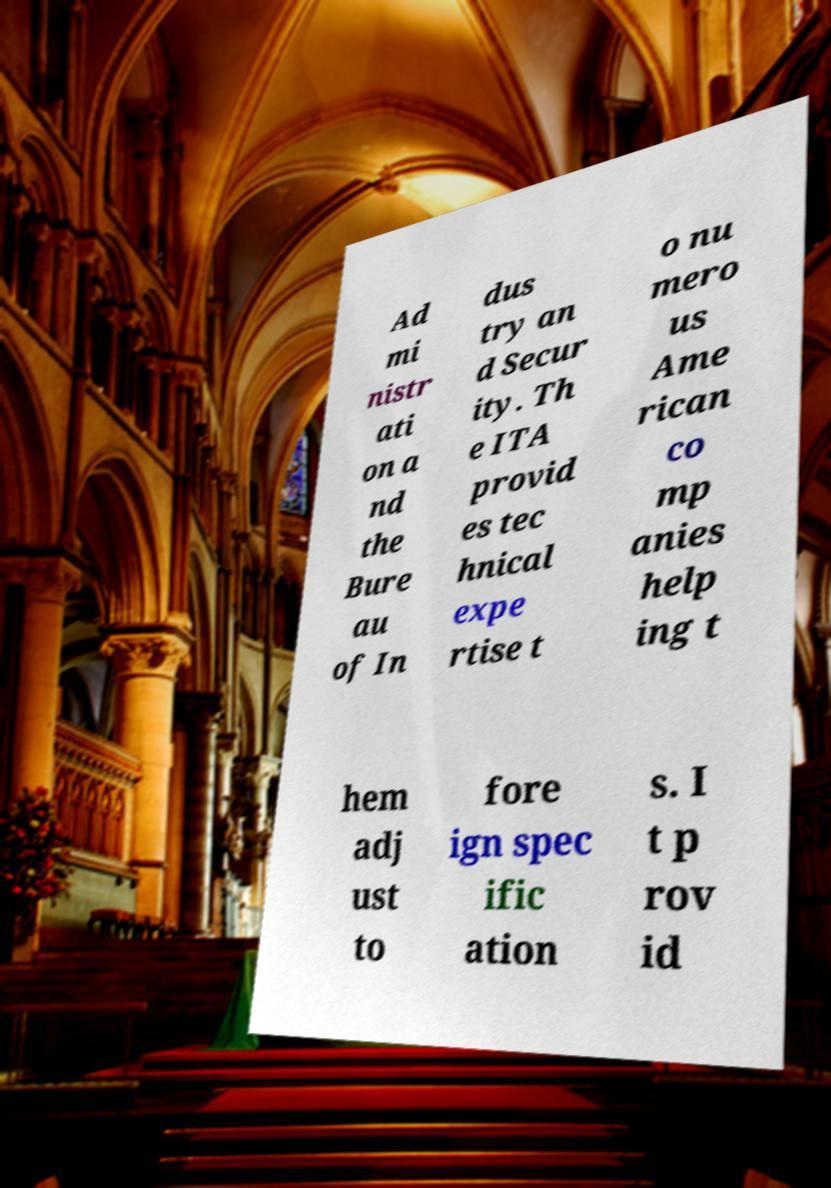What messages or text are displayed in this image? I need them in a readable, typed format. Ad mi nistr ati on a nd the Bure au of In dus try an d Secur ity. Th e ITA provid es tec hnical expe rtise t o nu mero us Ame rican co mp anies help ing t hem adj ust to fore ign spec ific ation s. I t p rov id 